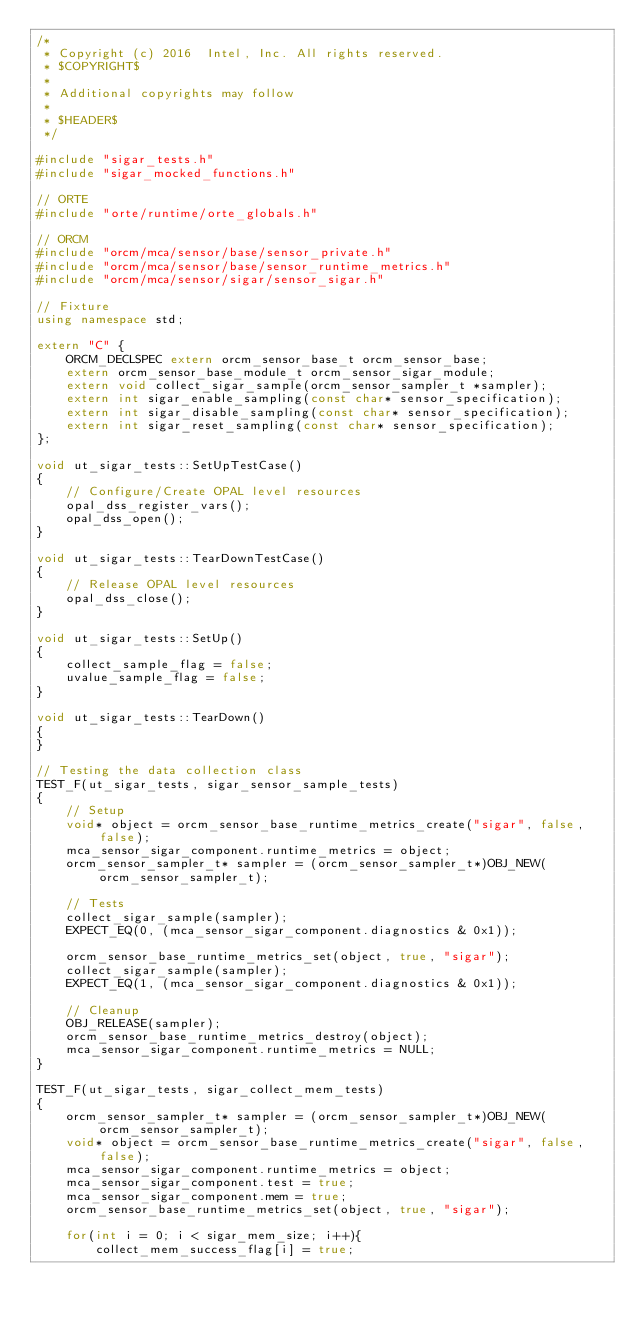<code> <loc_0><loc_0><loc_500><loc_500><_C++_>/*
 * Copyright (c) 2016  Intel, Inc. All rights reserved.
 * $COPYRIGHT$
 *
 * Additional copyrights may follow
 *
 * $HEADER$
 */

#include "sigar_tests.h"
#include "sigar_mocked_functions.h"

// ORTE
#include "orte/runtime/orte_globals.h"

// ORCM
#include "orcm/mca/sensor/base/sensor_private.h"
#include "orcm/mca/sensor/base/sensor_runtime_metrics.h"
#include "orcm/mca/sensor/sigar/sensor_sigar.h"

// Fixture
using namespace std;

extern "C" {
    ORCM_DECLSPEC extern orcm_sensor_base_t orcm_sensor_base;
    extern orcm_sensor_base_module_t orcm_sensor_sigar_module;
    extern void collect_sigar_sample(orcm_sensor_sampler_t *sampler);
    extern int sigar_enable_sampling(const char* sensor_specification);
    extern int sigar_disable_sampling(const char* sensor_specification);
    extern int sigar_reset_sampling(const char* sensor_specification);
};

void ut_sigar_tests::SetUpTestCase()
{
    // Configure/Create OPAL level resources
    opal_dss_register_vars();
    opal_dss_open();
}

void ut_sigar_tests::TearDownTestCase()
{
    // Release OPAL level resources
    opal_dss_close();
}

void ut_sigar_tests::SetUp()
{
    collect_sample_flag = false;
    uvalue_sample_flag = false;
}

void ut_sigar_tests::TearDown()
{
}

// Testing the data collection class
TEST_F(ut_sigar_tests, sigar_sensor_sample_tests)
{
    // Setup
    void* object = orcm_sensor_base_runtime_metrics_create("sigar", false, false);
    mca_sensor_sigar_component.runtime_metrics = object;
    orcm_sensor_sampler_t* sampler = (orcm_sensor_sampler_t*)OBJ_NEW(orcm_sensor_sampler_t);

    // Tests
    collect_sigar_sample(sampler);
    EXPECT_EQ(0, (mca_sensor_sigar_component.diagnostics & 0x1));

    orcm_sensor_base_runtime_metrics_set(object, true, "sigar");
    collect_sigar_sample(sampler);
    EXPECT_EQ(1, (mca_sensor_sigar_component.diagnostics & 0x1));

    // Cleanup
    OBJ_RELEASE(sampler);
    orcm_sensor_base_runtime_metrics_destroy(object);
    mca_sensor_sigar_component.runtime_metrics = NULL;
}

TEST_F(ut_sigar_tests, sigar_collect_mem_tests)
{
    orcm_sensor_sampler_t* sampler = (orcm_sensor_sampler_t*)OBJ_NEW(orcm_sensor_sampler_t);
    void* object = orcm_sensor_base_runtime_metrics_create("sigar", false, false);
    mca_sensor_sigar_component.runtime_metrics = object;
    mca_sensor_sigar_component.test = true;
    mca_sensor_sigar_component.mem = true;
    orcm_sensor_base_runtime_metrics_set(object, true, "sigar");

    for(int i = 0; i < sigar_mem_size; i++){
        collect_mem_success_flag[i] = true;</code> 